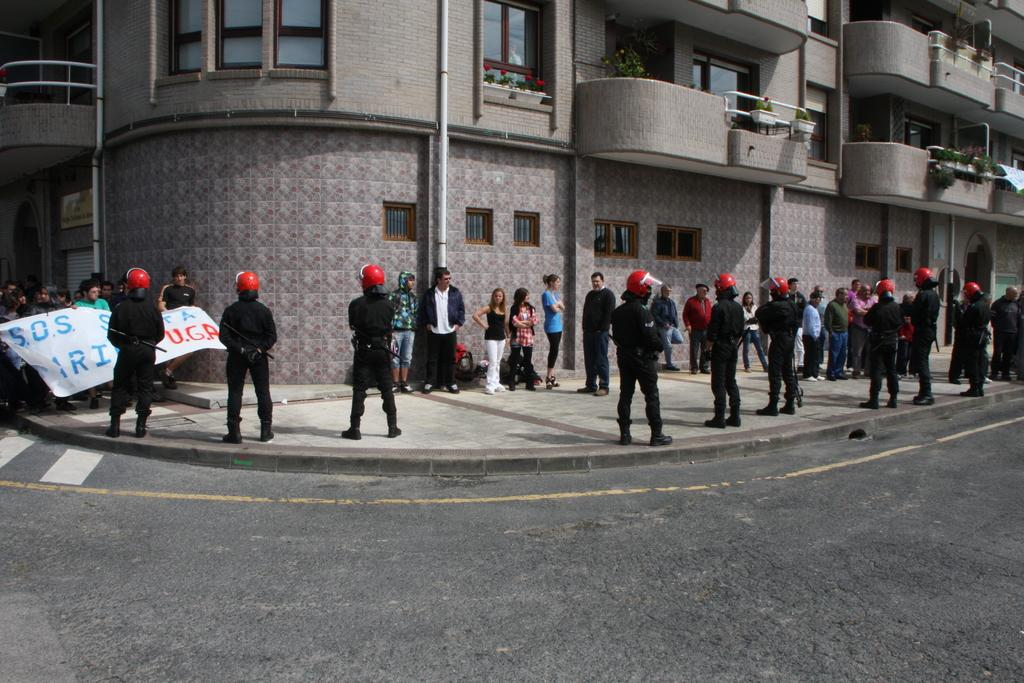What is located at the bottom of the image? There is a road at the bottom of the image. What can be seen in the background of the image? There is a building in the background of the image. What features does the building have? The building has doors and windows. Are there any plants visible near the building? Yes, there are potted plants near the building. Can you describe the people in the background of the image? There are people in the background of the image, but their specific actions or characteristics are not mentioned in the facts. What type of fruit is being served at the birthday celebration in the image? There is no mention of a birthday celebration or fruit in the image. The image features a road, a building with doors and windows, potted plants, and people in the background. 